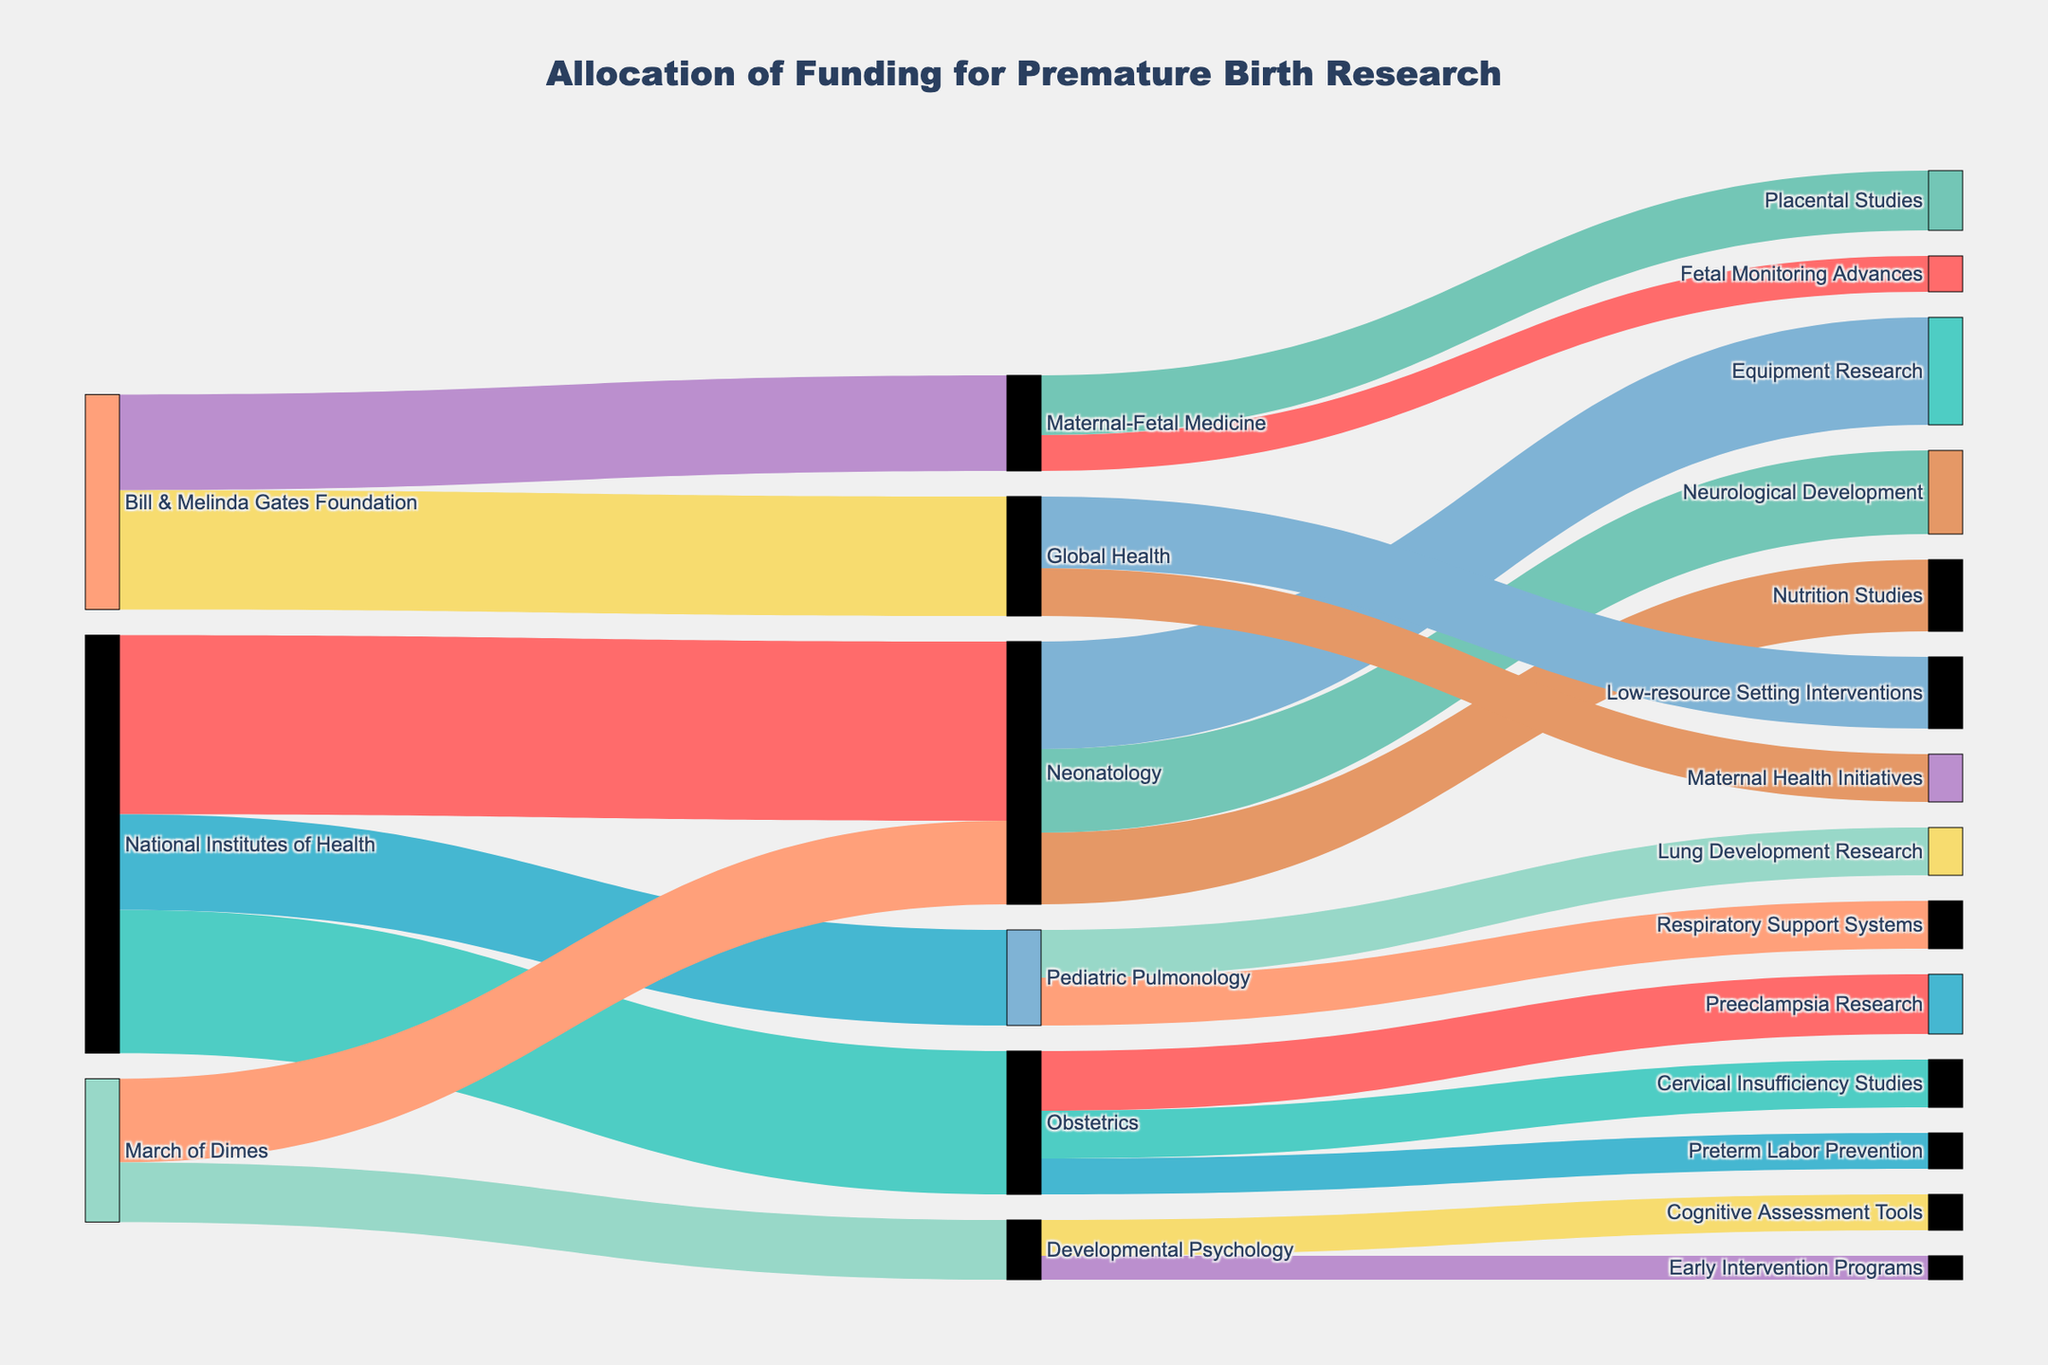What is the total funding allocated by the National Institutes of Health? Add up all the direct funding amounts allocated by the National Institutes of Health (Neonatology: 15,000,000 + Obstetrics: 12,000,000 + Pediatric Pulmonology: 8,000,000).
Answer: 35,000,000 Which medical specialty received the highest funding? Sum up the funding allocated to each medical specialty and identify the highest. Neonatology receives: 15,000,000 (NIH) + 7,000,000 (March of Dimes) = 22,000,000; Obstetrics receives 12,000,000; Pediatric Pulmonology receives 8,000,000; Developmental Psychology receives 5,000,000; Global Health receives 10,000,000; Maternal-Fetal Medicine receives 8,000,000. Neonatology has the highest funding.
Answer: Neonatology Which organization allocated the most funding to Neonatology? Compare the amounts allocated to Neonatology by each organization. National Institutes of Health: 15,000,000; March of Dimes: 7,000,000. National Institutes of Health has allocated the most.
Answer: National Institutes of Health What is the total funding allocated to Developmental Psychology and how does it compare to that allocated to Pediatric Pulmonology? Sum the total funding for Developmental Psychology (March of Dimes: 5,000,000), and compare it to the total funding for Pediatric Pulmonology (National Institutes of Health: 8,000,000). Developmental Psychology: 5,000,000; Pediatric Pulmonology: 8,000,000. Therefore, Pediatric Pulmonology received more.
Answer: Pediatric Pulmonology received more How much funding was directed towards placental studies? Identify the amount allocated to placental studies which is under Maternal-Fetal Medicine: 5,000,000.
Answer: 5,000,000 Which research category under Neonatology received the least funding? Compare the funding under different research categories within Neonatology: Equipment Research: 9,000,000, Nutrition Studies: 6,000,000, Neurological Development: 7,000,000. Nutrition Studies received the least.
Answer: Nutrition Studies How does funding for Preterm Labor Prevention compare to Preeclampsia Research under Obstetrics? Compare the funding allocated to each within Obstetrics: Preeclampsia Research receives 5,000,000 and Preterm Labor Prevention gets 3,000,000. Preeclampsia Research receives more.
Answer: Preeclampsia Research received more What is the combined funding for Cognitive Assessment Tools and Early Intervention Programs in Developmental Psychology? Add the funding allocated to Cognitive Assessment Tools (3,000,000) and Early Intervention Programs (2,000,000) under Developmental Psychology.
Answer: 5,000,000 How much total funding does Global Health receive and which is the larger project within it? Sum the total funding for Global Health and identify the largest allocation. Low-resource Setting Interventions: 6,000,000 + Maternal Health Initiatives: 4,000,000 = 10,000,000. Low-resource Setting Interventions receives more.
Answer: 10,000,000, Low-resource Setting Interventions 